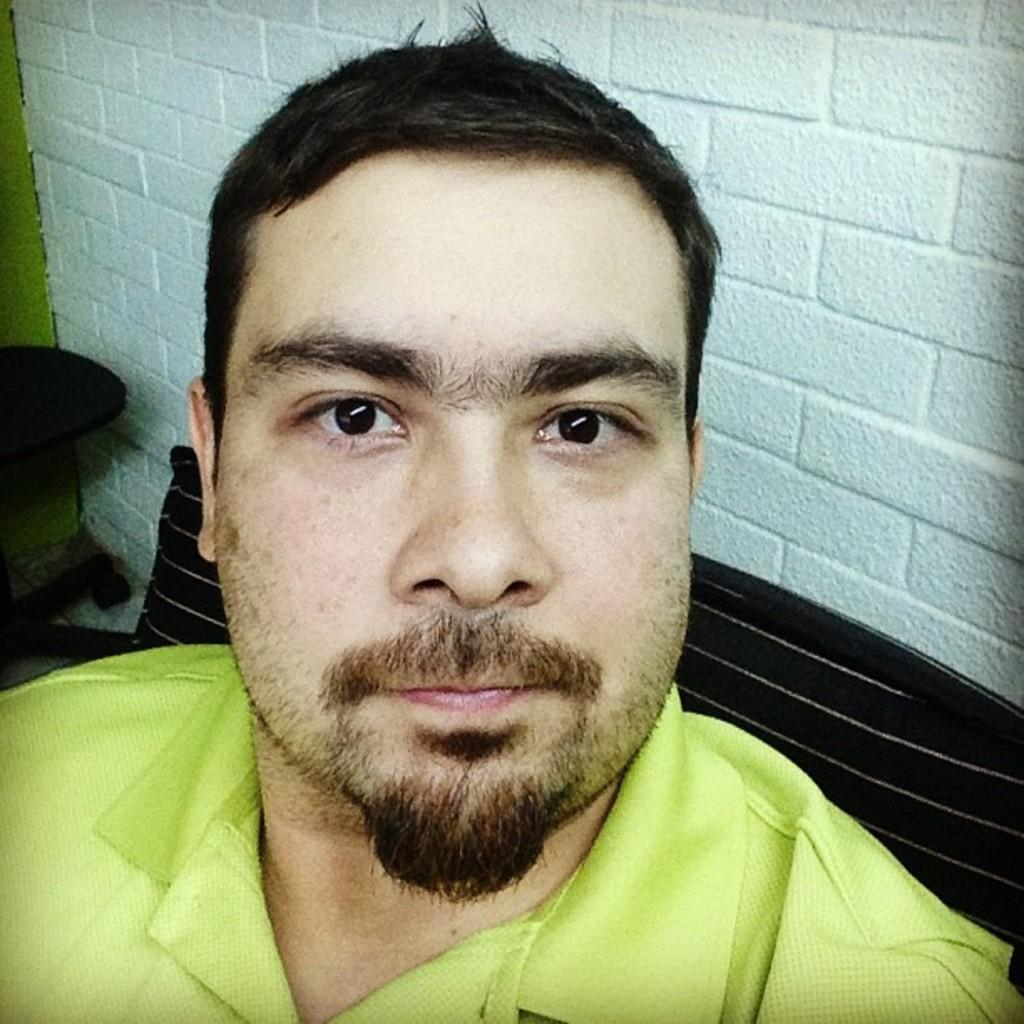Who is present in the image? There is a man in the image. What is the man doing in the image? The man is standing in the image. What is the man wearing in the image? The man is wearing a green T-shirt in the image. What can be seen in the background of the image? There is a bench and a wall in the background of the image. What colors are the bench and wall in the image? The bench is brown, and the wall is white in the image. What type of disease is the man suffering from in the image? There is no indication of any disease in the image; the man is simply standing and wearing a green T-shirt. 